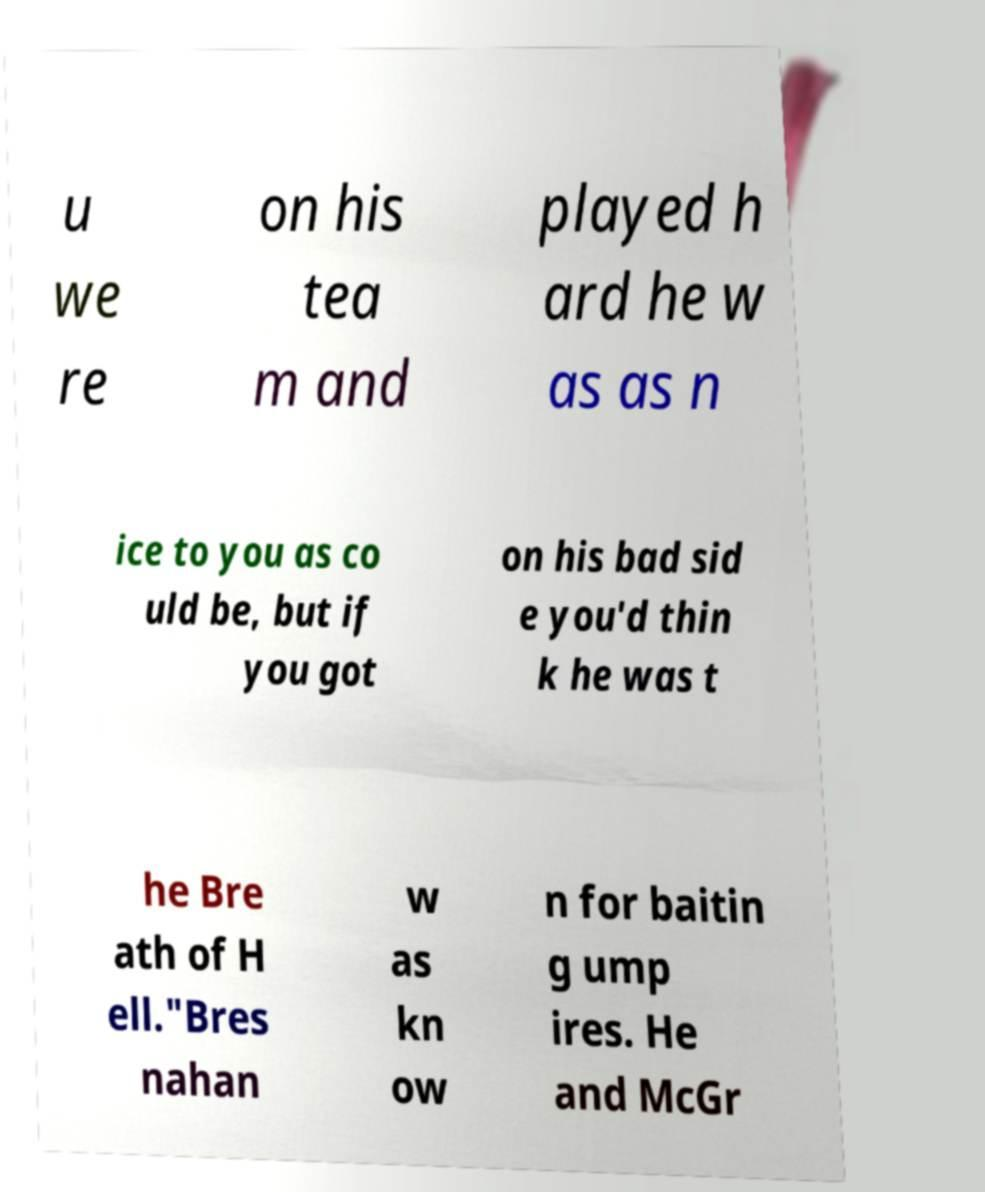What messages or text are displayed in this image? I need them in a readable, typed format. u we re on his tea m and played h ard he w as as n ice to you as co uld be, but if you got on his bad sid e you'd thin k he was t he Bre ath of H ell."Bres nahan w as kn ow n for baitin g ump ires. He and McGr 